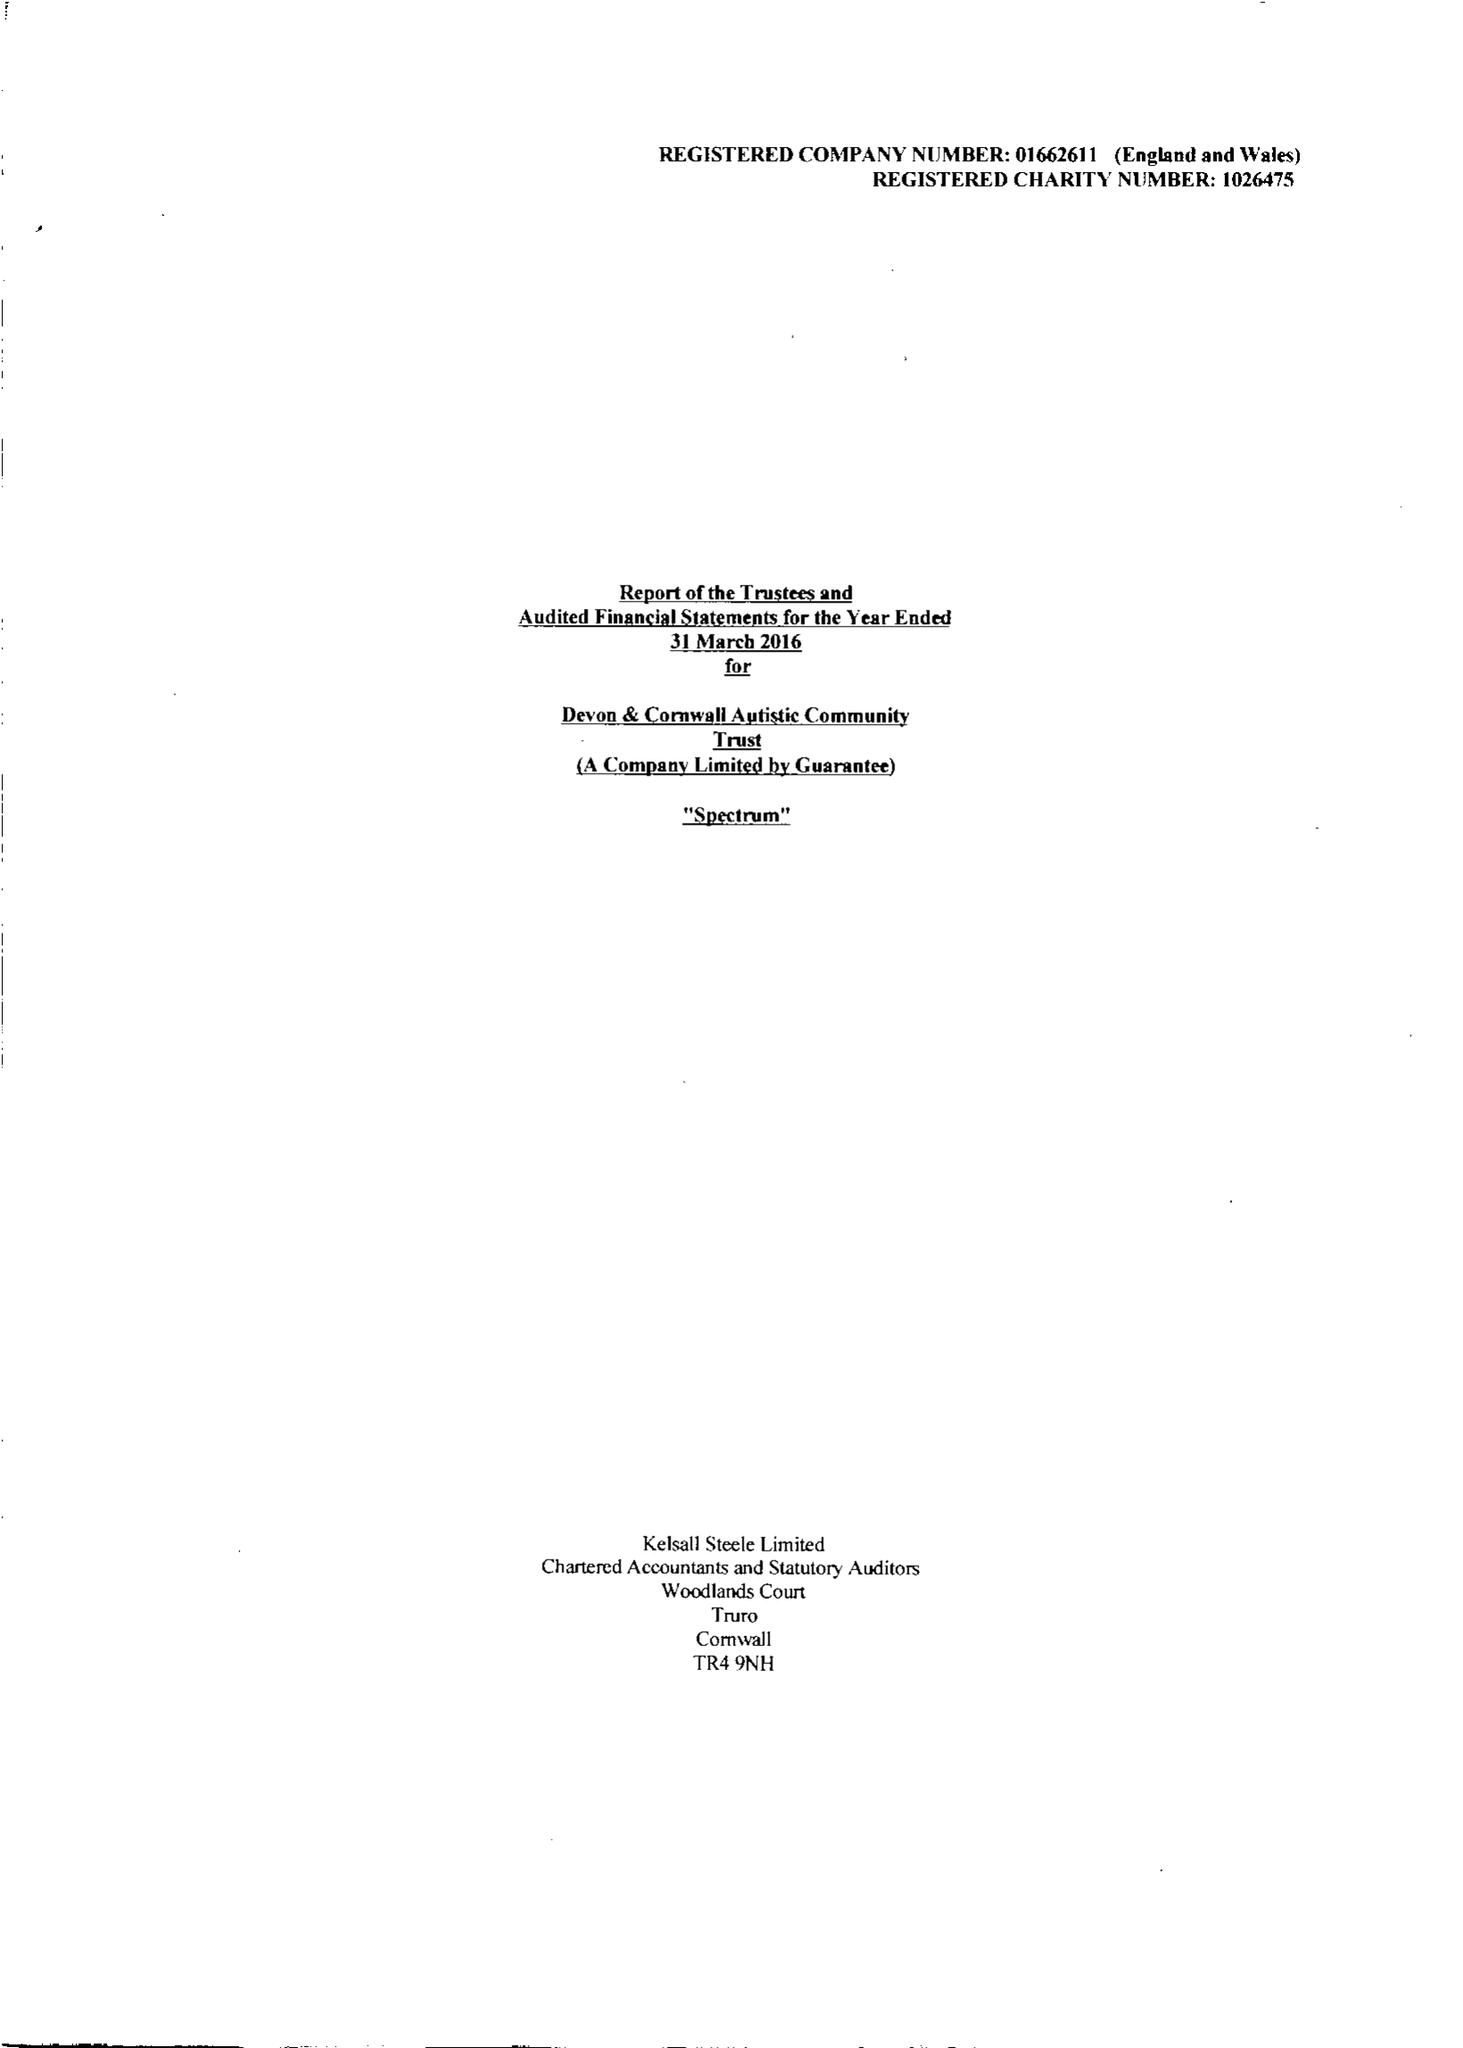What is the value for the charity_number?
Answer the question using a single word or phrase. 1026475 